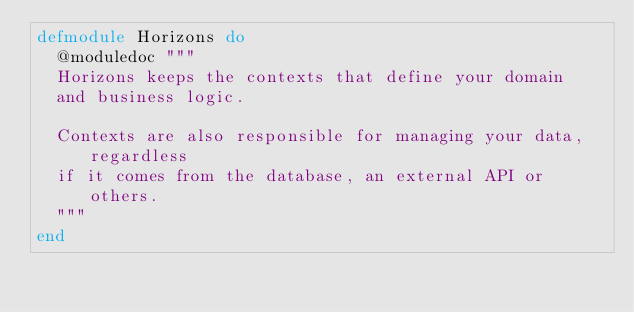Convert code to text. <code><loc_0><loc_0><loc_500><loc_500><_Elixir_>defmodule Horizons do
  @moduledoc """
  Horizons keeps the contexts that define your domain
  and business logic.

  Contexts are also responsible for managing your data, regardless
  if it comes from the database, an external API or others.
  """
end
</code> 